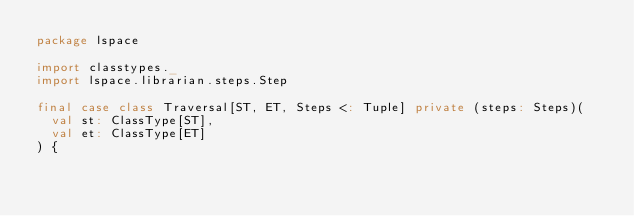Convert code to text. <code><loc_0><loc_0><loc_500><loc_500><_Scala_>package lspace

import classtypes._
import lspace.librarian.steps.Step

final case class Traversal[ST, ET, Steps <: Tuple] private (steps: Steps)(
  val st: ClassType[ST],
  val et: ClassType[ET]
) {
</code> 